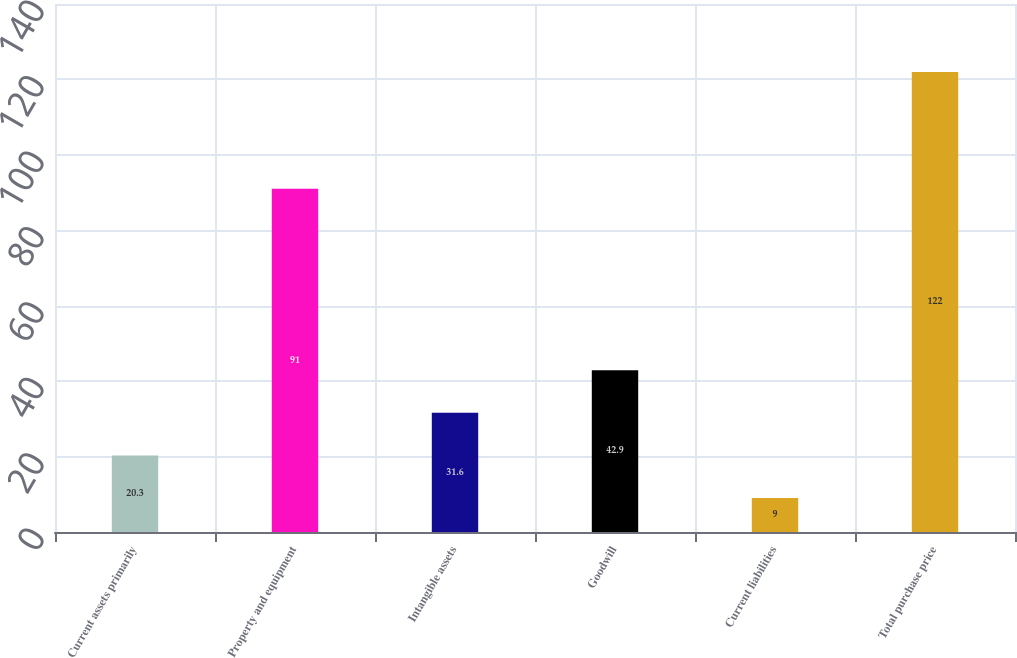<chart> <loc_0><loc_0><loc_500><loc_500><bar_chart><fcel>Current assets primarily<fcel>Property and equipment<fcel>Intangible assets<fcel>Goodwill<fcel>Current liabilities<fcel>Total purchase price<nl><fcel>20.3<fcel>91<fcel>31.6<fcel>42.9<fcel>9<fcel>122<nl></chart> 